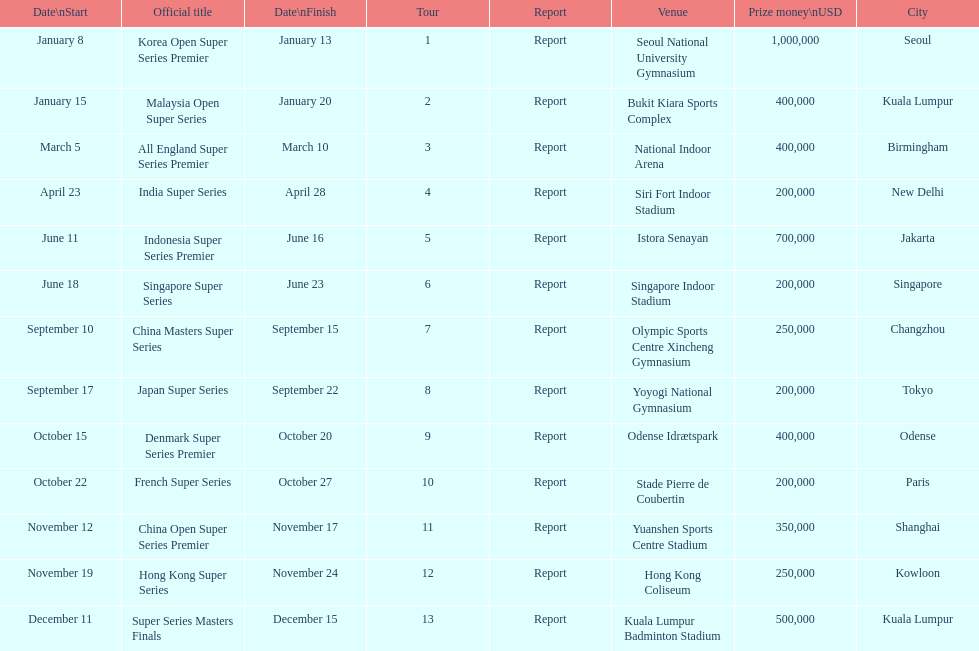Which tour was the only one to take place in december? Super Series Masters Finals. 